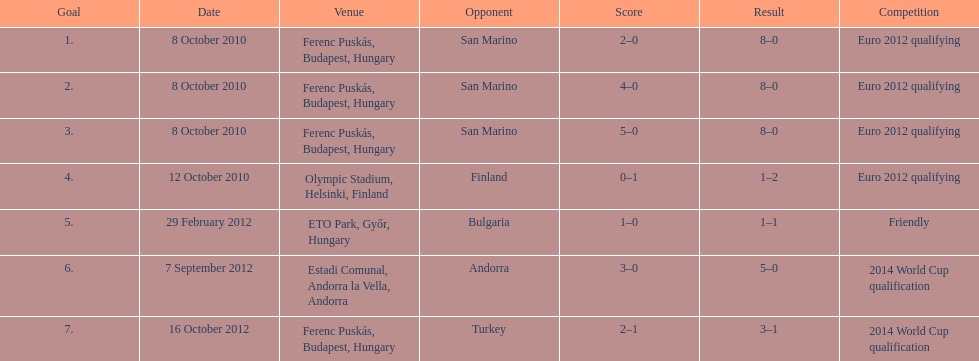What is the sum of goals made in the euro 2012 qualifying event? 12. 